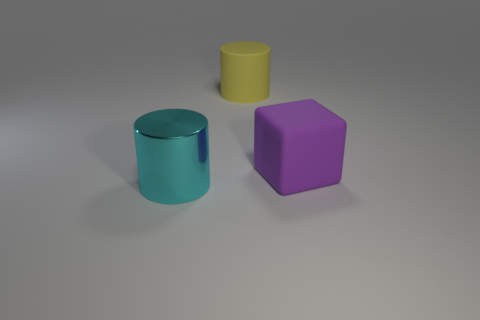Add 1 large cyan matte cylinders. How many objects exist? 4 Subtract 1 cylinders. How many cylinders are left? 1 Subtract all tiny green balls. Subtract all matte objects. How many objects are left? 1 Add 1 cubes. How many cubes are left? 2 Add 3 large yellow shiny balls. How many large yellow shiny balls exist? 3 Subtract 0 gray blocks. How many objects are left? 3 Subtract all cubes. How many objects are left? 2 Subtract all green cylinders. Subtract all yellow cubes. How many cylinders are left? 2 Subtract all purple balls. How many yellow cylinders are left? 1 